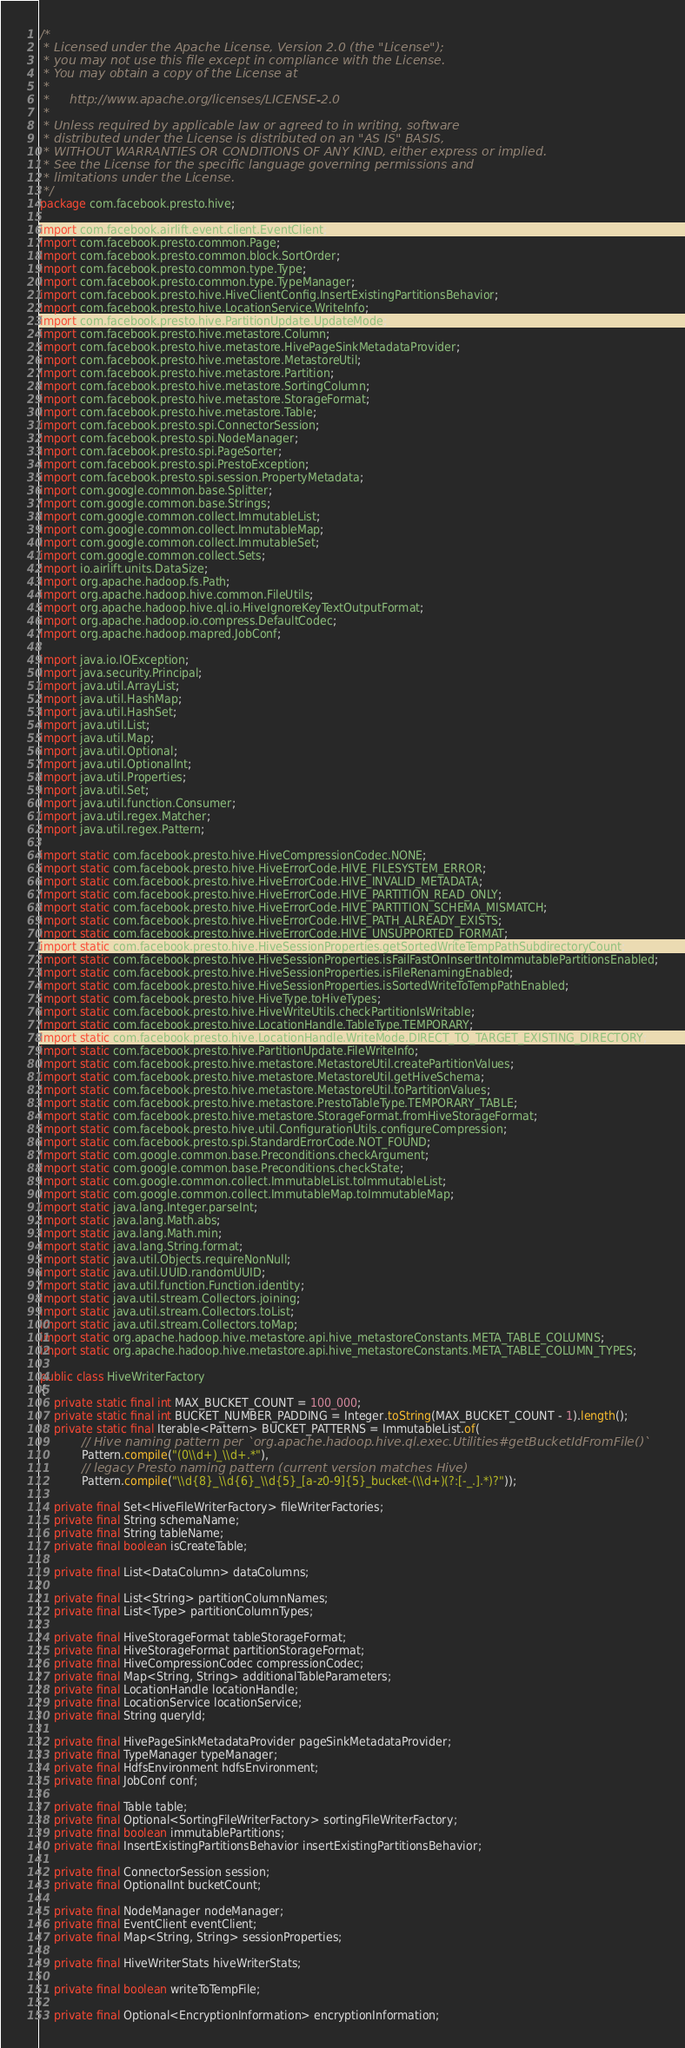<code> <loc_0><loc_0><loc_500><loc_500><_Java_>/*
 * Licensed under the Apache License, Version 2.0 (the "License");
 * you may not use this file except in compliance with the License.
 * You may obtain a copy of the License at
 *
 *     http://www.apache.org/licenses/LICENSE-2.0
 *
 * Unless required by applicable law or agreed to in writing, software
 * distributed under the License is distributed on an "AS IS" BASIS,
 * WITHOUT WARRANTIES OR CONDITIONS OF ANY KIND, either express or implied.
 * See the License for the specific language governing permissions and
 * limitations under the License.
 */
package com.facebook.presto.hive;

import com.facebook.airlift.event.client.EventClient;
import com.facebook.presto.common.Page;
import com.facebook.presto.common.block.SortOrder;
import com.facebook.presto.common.type.Type;
import com.facebook.presto.common.type.TypeManager;
import com.facebook.presto.hive.HiveClientConfig.InsertExistingPartitionsBehavior;
import com.facebook.presto.hive.LocationService.WriteInfo;
import com.facebook.presto.hive.PartitionUpdate.UpdateMode;
import com.facebook.presto.hive.metastore.Column;
import com.facebook.presto.hive.metastore.HivePageSinkMetadataProvider;
import com.facebook.presto.hive.metastore.MetastoreUtil;
import com.facebook.presto.hive.metastore.Partition;
import com.facebook.presto.hive.metastore.SortingColumn;
import com.facebook.presto.hive.metastore.StorageFormat;
import com.facebook.presto.hive.metastore.Table;
import com.facebook.presto.spi.ConnectorSession;
import com.facebook.presto.spi.NodeManager;
import com.facebook.presto.spi.PageSorter;
import com.facebook.presto.spi.PrestoException;
import com.facebook.presto.spi.session.PropertyMetadata;
import com.google.common.base.Splitter;
import com.google.common.base.Strings;
import com.google.common.collect.ImmutableList;
import com.google.common.collect.ImmutableMap;
import com.google.common.collect.ImmutableSet;
import com.google.common.collect.Sets;
import io.airlift.units.DataSize;
import org.apache.hadoop.fs.Path;
import org.apache.hadoop.hive.common.FileUtils;
import org.apache.hadoop.hive.ql.io.HiveIgnoreKeyTextOutputFormat;
import org.apache.hadoop.io.compress.DefaultCodec;
import org.apache.hadoop.mapred.JobConf;

import java.io.IOException;
import java.security.Principal;
import java.util.ArrayList;
import java.util.HashMap;
import java.util.HashSet;
import java.util.List;
import java.util.Map;
import java.util.Optional;
import java.util.OptionalInt;
import java.util.Properties;
import java.util.Set;
import java.util.function.Consumer;
import java.util.regex.Matcher;
import java.util.regex.Pattern;

import static com.facebook.presto.hive.HiveCompressionCodec.NONE;
import static com.facebook.presto.hive.HiveErrorCode.HIVE_FILESYSTEM_ERROR;
import static com.facebook.presto.hive.HiveErrorCode.HIVE_INVALID_METADATA;
import static com.facebook.presto.hive.HiveErrorCode.HIVE_PARTITION_READ_ONLY;
import static com.facebook.presto.hive.HiveErrorCode.HIVE_PARTITION_SCHEMA_MISMATCH;
import static com.facebook.presto.hive.HiveErrorCode.HIVE_PATH_ALREADY_EXISTS;
import static com.facebook.presto.hive.HiveErrorCode.HIVE_UNSUPPORTED_FORMAT;
import static com.facebook.presto.hive.HiveSessionProperties.getSortedWriteTempPathSubdirectoryCount;
import static com.facebook.presto.hive.HiveSessionProperties.isFailFastOnInsertIntoImmutablePartitionsEnabled;
import static com.facebook.presto.hive.HiveSessionProperties.isFileRenamingEnabled;
import static com.facebook.presto.hive.HiveSessionProperties.isSortedWriteToTempPathEnabled;
import static com.facebook.presto.hive.HiveType.toHiveTypes;
import static com.facebook.presto.hive.HiveWriteUtils.checkPartitionIsWritable;
import static com.facebook.presto.hive.LocationHandle.TableType.TEMPORARY;
import static com.facebook.presto.hive.LocationHandle.WriteMode.DIRECT_TO_TARGET_EXISTING_DIRECTORY;
import static com.facebook.presto.hive.PartitionUpdate.FileWriteInfo;
import static com.facebook.presto.hive.metastore.MetastoreUtil.createPartitionValues;
import static com.facebook.presto.hive.metastore.MetastoreUtil.getHiveSchema;
import static com.facebook.presto.hive.metastore.MetastoreUtil.toPartitionValues;
import static com.facebook.presto.hive.metastore.PrestoTableType.TEMPORARY_TABLE;
import static com.facebook.presto.hive.metastore.StorageFormat.fromHiveStorageFormat;
import static com.facebook.presto.hive.util.ConfigurationUtils.configureCompression;
import static com.facebook.presto.spi.StandardErrorCode.NOT_FOUND;
import static com.google.common.base.Preconditions.checkArgument;
import static com.google.common.base.Preconditions.checkState;
import static com.google.common.collect.ImmutableList.toImmutableList;
import static com.google.common.collect.ImmutableMap.toImmutableMap;
import static java.lang.Integer.parseInt;
import static java.lang.Math.abs;
import static java.lang.Math.min;
import static java.lang.String.format;
import static java.util.Objects.requireNonNull;
import static java.util.UUID.randomUUID;
import static java.util.function.Function.identity;
import static java.util.stream.Collectors.joining;
import static java.util.stream.Collectors.toList;
import static java.util.stream.Collectors.toMap;
import static org.apache.hadoop.hive.metastore.api.hive_metastoreConstants.META_TABLE_COLUMNS;
import static org.apache.hadoop.hive.metastore.api.hive_metastoreConstants.META_TABLE_COLUMN_TYPES;

public class HiveWriterFactory
{
    private static final int MAX_BUCKET_COUNT = 100_000;
    private static final int BUCKET_NUMBER_PADDING = Integer.toString(MAX_BUCKET_COUNT - 1).length();
    private static final Iterable<Pattern> BUCKET_PATTERNS = ImmutableList.of(
            // Hive naming pattern per `org.apache.hadoop.hive.ql.exec.Utilities#getBucketIdFromFile()`
            Pattern.compile("(0\\d+)_\\d+.*"),
            // legacy Presto naming pattern (current version matches Hive)
            Pattern.compile("\\d{8}_\\d{6}_\\d{5}_[a-z0-9]{5}_bucket-(\\d+)(?:[-_.].*)?"));

    private final Set<HiveFileWriterFactory> fileWriterFactories;
    private final String schemaName;
    private final String tableName;
    private final boolean isCreateTable;

    private final List<DataColumn> dataColumns;

    private final List<String> partitionColumnNames;
    private final List<Type> partitionColumnTypes;

    private final HiveStorageFormat tableStorageFormat;
    private final HiveStorageFormat partitionStorageFormat;
    private final HiveCompressionCodec compressionCodec;
    private final Map<String, String> additionalTableParameters;
    private final LocationHandle locationHandle;
    private final LocationService locationService;
    private final String queryId;

    private final HivePageSinkMetadataProvider pageSinkMetadataProvider;
    private final TypeManager typeManager;
    private final HdfsEnvironment hdfsEnvironment;
    private final JobConf conf;

    private final Table table;
    private final Optional<SortingFileWriterFactory> sortingFileWriterFactory;
    private final boolean immutablePartitions;
    private final InsertExistingPartitionsBehavior insertExistingPartitionsBehavior;

    private final ConnectorSession session;
    private final OptionalInt bucketCount;

    private final NodeManager nodeManager;
    private final EventClient eventClient;
    private final Map<String, String> sessionProperties;

    private final HiveWriterStats hiveWriterStats;

    private final boolean writeToTempFile;

    private final Optional<EncryptionInformation> encryptionInformation;
</code> 